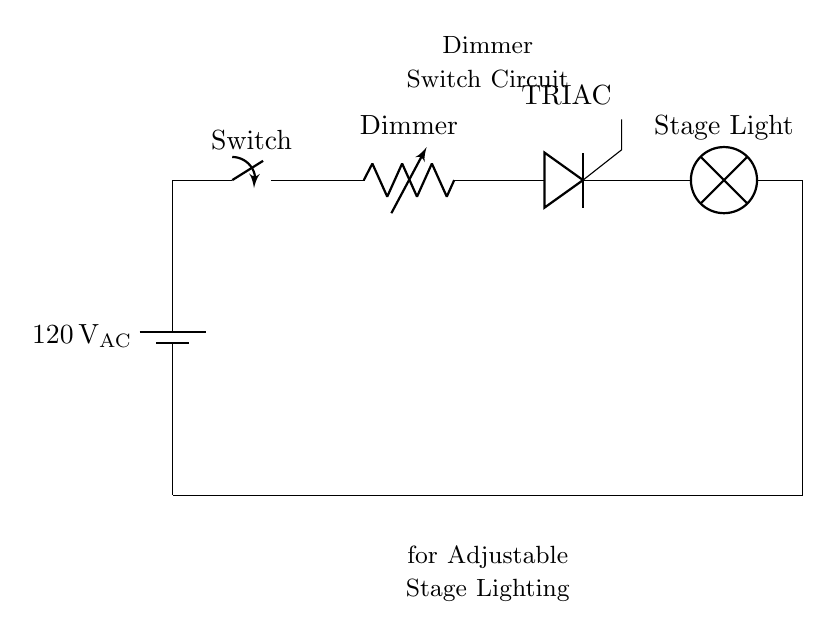What is the voltage of this circuit? The circuit operates at AC voltage, and it is specified as one hundred twenty volts. This is indicated next to the battery component in the diagram.
Answer: one hundred twenty volts What type of switch is used in the circuit? The component labeled as "Switch" is a general switch type, but given the context of a dimmer switch circuit, it’s reasonable to infer that this is a standard on-off switch.
Answer: Switch What is the purpose of the TRIAC in this circuit? The TRIAC is used for controlling power flow to the load (stage light) by switching on and off rapidly as the dimmer adjusts its resistance. This allows for dimming capabilities in the lighting setup.
Answer: Control power flow How does the dimmer influence the stage lighting? The dimmer, labeled as a variable resistor, alters the resistance in the circuit. By adjusting this resistance, it changes the amount of current flowing to the stage light, thus controlling the brightness of the lamp.
Answer: Adjusts brightness What happens to the stage light when the switch is closed? When the switch is closed, it completes the circuit, allowing current to flow through the dimmer and TRIAC to the stage light, causing it to turn on.
Answer: Stage light turns on What is the load of this circuit? The load refers to the device that consumes electrical power, in this case, the stage light indicated in the diagram.
Answer: Stage light 